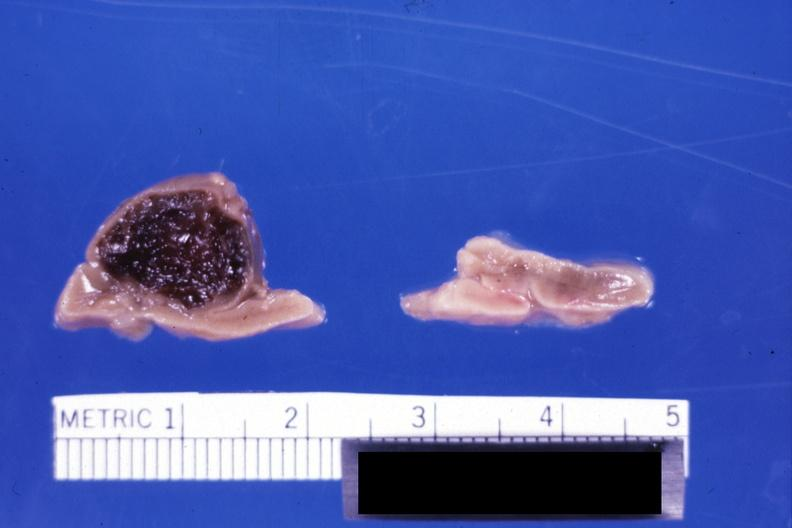s adrenal present?
Answer the question using a single word or phrase. Yes 